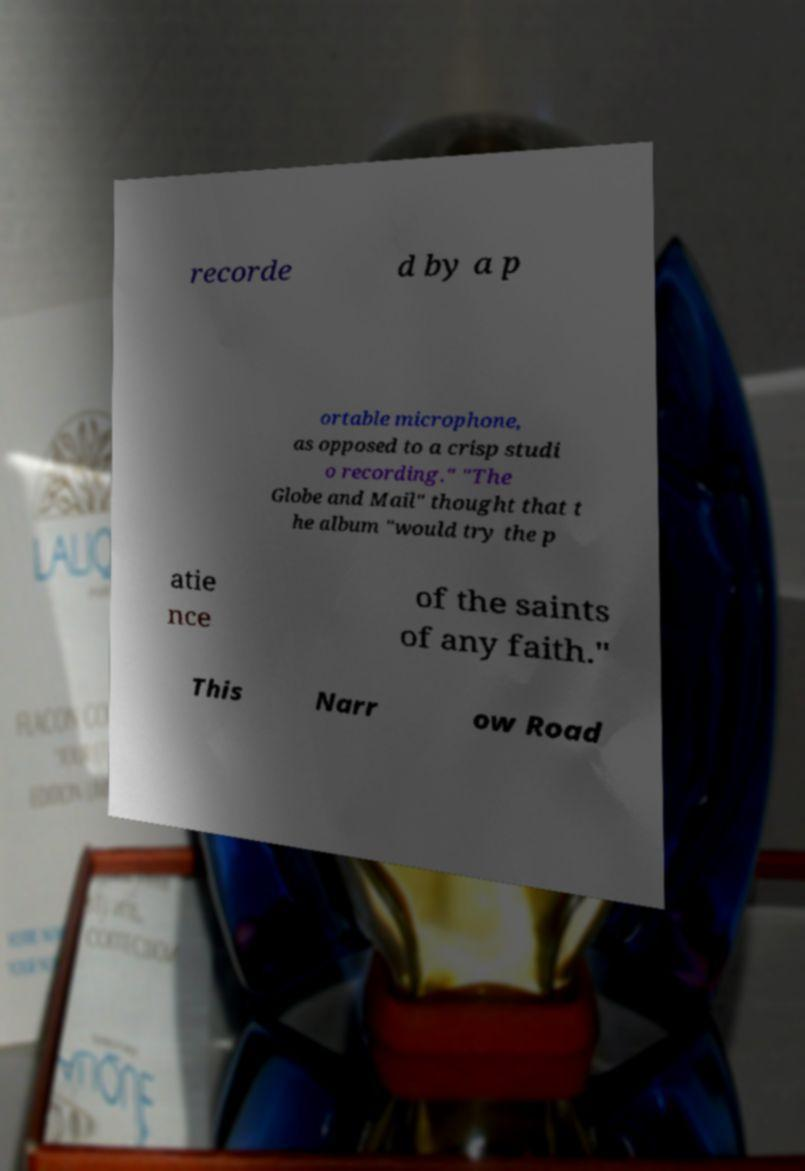I need the written content from this picture converted into text. Can you do that? recorde d by a p ortable microphone, as opposed to a crisp studi o recording." "The Globe and Mail" thought that t he album "would try the p atie nce of the saints of any faith." This Narr ow Road 